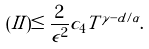Convert formula to latex. <formula><loc_0><loc_0><loc_500><loc_500>( I I ) \leq \frac { 2 } { \epsilon ^ { 2 } } c _ { 4 } T ^ { \gamma - d / \alpha } .</formula> 